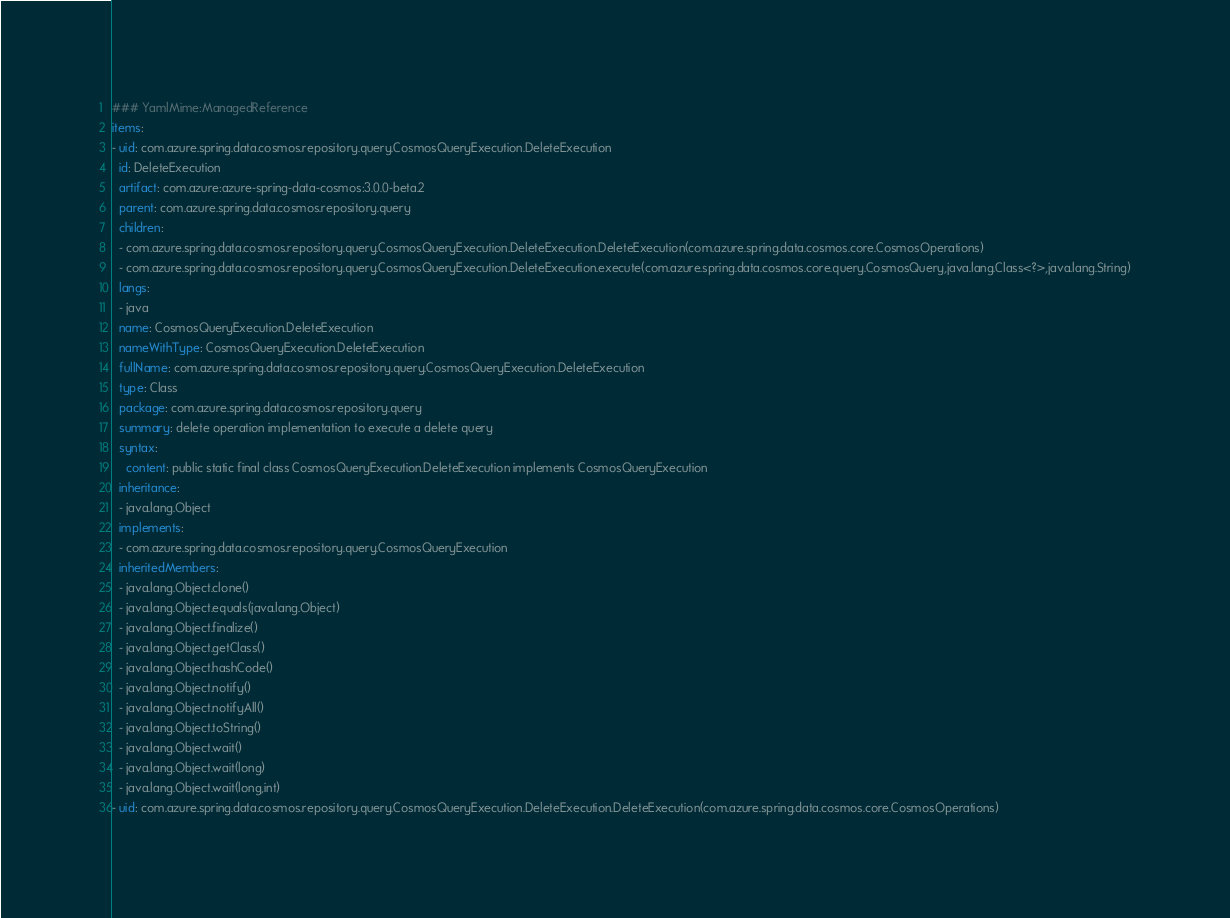Convert code to text. <code><loc_0><loc_0><loc_500><loc_500><_YAML_>### YamlMime:ManagedReference
items:
- uid: com.azure.spring.data.cosmos.repository.query.CosmosQueryExecution.DeleteExecution
  id: DeleteExecution
  artifact: com.azure:azure-spring-data-cosmos:3.0.0-beta.2
  parent: com.azure.spring.data.cosmos.repository.query
  children:
  - com.azure.spring.data.cosmos.repository.query.CosmosQueryExecution.DeleteExecution.DeleteExecution(com.azure.spring.data.cosmos.core.CosmosOperations)
  - com.azure.spring.data.cosmos.repository.query.CosmosQueryExecution.DeleteExecution.execute(com.azure.spring.data.cosmos.core.query.CosmosQuery,java.lang.Class<?>,java.lang.String)
  langs:
  - java
  name: CosmosQueryExecution.DeleteExecution
  nameWithType: CosmosQueryExecution.DeleteExecution
  fullName: com.azure.spring.data.cosmos.repository.query.CosmosQueryExecution.DeleteExecution
  type: Class
  package: com.azure.spring.data.cosmos.repository.query
  summary: delete operation implementation to execute a delete query
  syntax:
    content: public static final class CosmosQueryExecution.DeleteExecution implements CosmosQueryExecution
  inheritance:
  - java.lang.Object
  implements:
  - com.azure.spring.data.cosmos.repository.query.CosmosQueryExecution
  inheritedMembers:
  - java.lang.Object.clone()
  - java.lang.Object.equals(java.lang.Object)
  - java.lang.Object.finalize()
  - java.lang.Object.getClass()
  - java.lang.Object.hashCode()
  - java.lang.Object.notify()
  - java.lang.Object.notifyAll()
  - java.lang.Object.toString()
  - java.lang.Object.wait()
  - java.lang.Object.wait(long)
  - java.lang.Object.wait(long,int)
- uid: com.azure.spring.data.cosmos.repository.query.CosmosQueryExecution.DeleteExecution.DeleteExecution(com.azure.spring.data.cosmos.core.CosmosOperations)</code> 